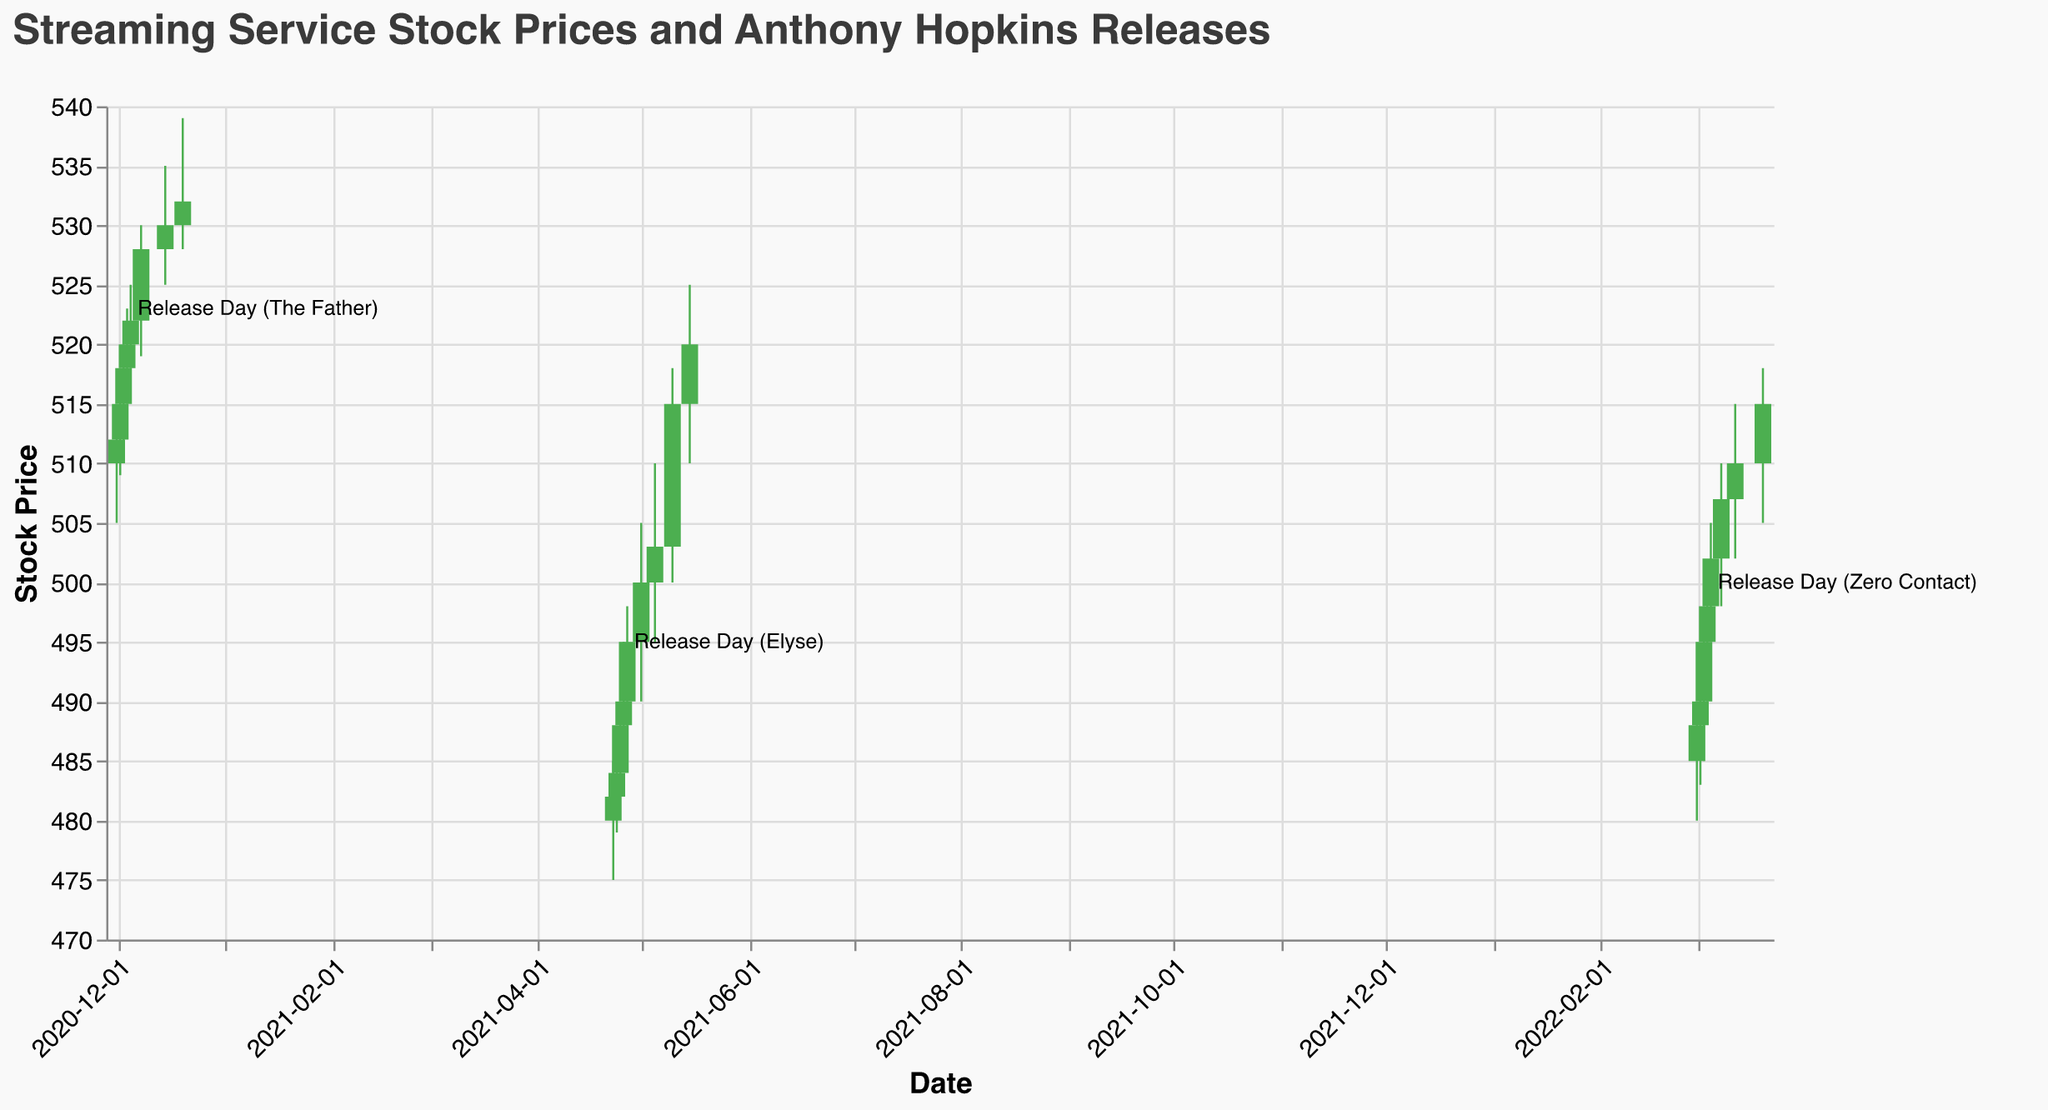What's the title of the figure? The title is usually located at the top of the figure. In this case, it reads "Streaming Service Stock Prices and Anthony Hopkins Releases"
Answer: Streaming Service Stock Prices and Anthony Hopkins Releases What is the stock price range on the y-axis? The y-axis displays the stock price range, which includes the scale from 470 to 540. This can be seen by examining the y-axis on the left side of the figure.
Answer: 470 to 540 During which release period was the highest closing price observed for the streaming service stock? The highest closing price can be identified by looking at the top of the candlesticks. For Release Day (The Father), the closing price is 520, but during Post-Release Hype (The Father), the closing price is 522. This trend continues and further verification shows that for Festival Awards, the closing price is 532, which is the highest.
Answer: Festival Awards How did the stock price change from the opening (Pre-Release) to the closing (Festival Awards) during the release period of "The Father"? To find this, check the opening price on 2020-12-01 (Pre-Release), which is 510, and the closing price on 2020-12-20 (Festival Awards), which is 532. The stock price increased from 510 to 532 during this period.
Answer: Increased from 510 to 532 Which release period showed the largest single-day price drop, and by how much? Check for the largest difference between the high and low prices on any single day. Comparing the differences visually, on 2021-05-10 (Sustained Ratings), the high was 518, and the low was 500, making the drop 518 - 500 = 18.
Answer: Sustained Ratings, 18 points What pattern is observed in stock price changes during the different release phases of "Elyse"? Observe the trend during the "Elyse" release phases. Pre-Release starts with 480 and closes slightly higher. The Oscars Nomination led to an increase to 488. After the Release Day, the price continues to increase, peaking after the Post-Release Uptick and Audience Reception, following a rising trend.
Answer: Increasing trend How does the stock performance correlate with the release date of "Zero Contact"? Reviewing the data points around the Zero Contact release, before the release on 2022-03-03, the price starts at 485 and goes up to a peak of 510 by 2022-03-12, showing an upward trend around the release event.
Answer: Upward trend Which release saw the highest trading volume and what was the volume? By scanning the volume values, Festival Awards (2020-12-20) has the highest volume at 4900000.
Answer: Festival Awards, 4900000 During which release was the stock price above 500 the most consistently? By analyzing the closing prices, it's evident that the stock price stayed above 500 most consistently during the release phases of "Zero Contact," from 2022-03-04 to 2022-03-20.
Answer: Zero Contact What is the average closing price during the "Sustained Ratings" phase? Identifying the dates and closing prices for "Sustained Ratings" (2021-05-10), the closing price is 515. Since it's a single date range, the average closing price is 515.
Answer: 515 